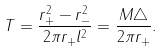<formula> <loc_0><loc_0><loc_500><loc_500>T = \frac { r _ { + } ^ { 2 } - r _ { - } ^ { 2 } } { 2 \pi r _ { + } l ^ { 2 } } = \frac { M \triangle } { 2 \pi r _ { + } } .</formula> 